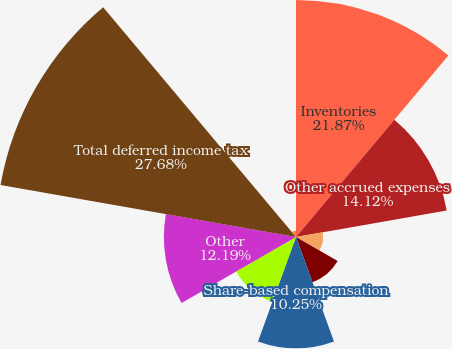<chart> <loc_0><loc_0><loc_500><loc_500><pie_chart><fcel>Inventories<fcel>Other accrued expenses<fcel>Depreciation and amortization<fcel>State income taxes<fcel>Share-based compensation<fcel>Net operating loss<fcel>Other<fcel>Total deferred income tax<fcel>Less valuation allowances<nl><fcel>21.87%<fcel>14.12%<fcel>2.5%<fcel>4.44%<fcel>10.25%<fcel>6.38%<fcel>12.19%<fcel>27.68%<fcel>0.57%<nl></chart> 